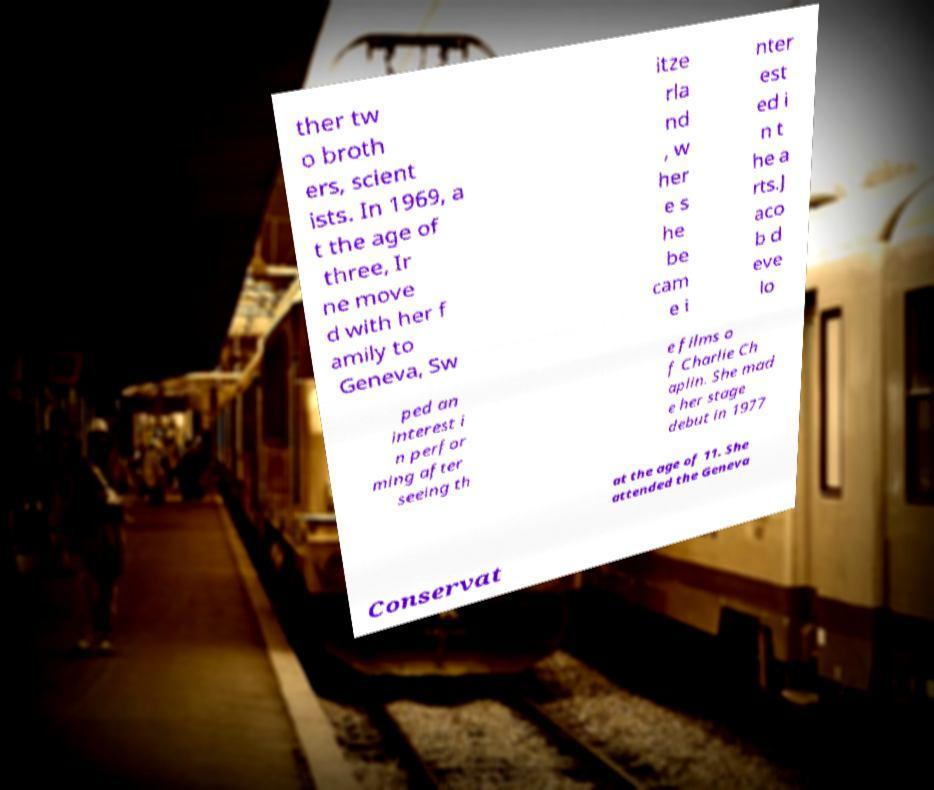Please read and relay the text visible in this image. What does it say? ther tw o broth ers, scient ists. In 1969, a t the age of three, Ir ne move d with her f amily to Geneva, Sw itze rla nd , w her e s he be cam e i nter est ed i n t he a rts.J aco b d eve lo ped an interest i n perfor ming after seeing th e films o f Charlie Ch aplin. She mad e her stage debut in 1977 at the age of 11. She attended the Geneva Conservat 